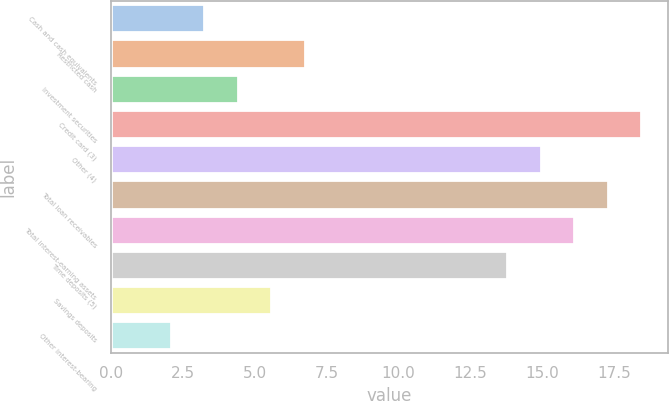<chart> <loc_0><loc_0><loc_500><loc_500><bar_chart><fcel>Cash and cash equivalents<fcel>Restricted cash<fcel>Investment securities<fcel>Credit card (3)<fcel>Other (4)<fcel>Total loan receivables<fcel>Total interest-earning assets<fcel>Time deposits (5)<fcel>Savings deposits<fcel>Other interest-bearing<nl><fcel>3.25<fcel>6.76<fcel>4.42<fcel>18.46<fcel>14.95<fcel>17.29<fcel>16.12<fcel>13.78<fcel>5.59<fcel>2.08<nl></chart> 